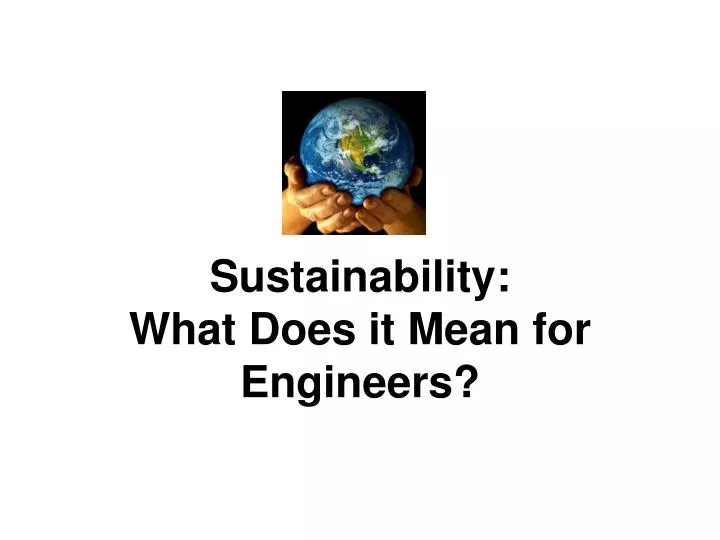If engineers were to design a futuristic environmentally-friendly amusement park, what innovative rides and attractions might they include? A futuristic, environmentally-friendly amusement park could feature the following rides and attractions:
1. **Solar Coaster**: A roller coaster powered entirely by solar energy, with panels integrated into the coaster’s tracks and surrounding structures.
2. **Eco-Friendly Water Rides**: Water rides using recycled water and innovative filtration systems to ensure no water wastage.
3. **Wind-Powered Ferris Wheel**: A Ferris wheel equipped with small wind turbines to generate its own electricity.
4. **Virtual Reality Adventures**: VR experiences that simulate thrilling rides without the need for large physical structures, reducing material use and energy consumption.
5. **Green Maze**: A maze constructed entirely from living plants and trees, promoting biodiversity and providing natural cooling.
6. **Pedal-Powered Rides**: Attractions where visitors can pedal to generate the power needed for the ride, promoting physical activity and energy awareness. 